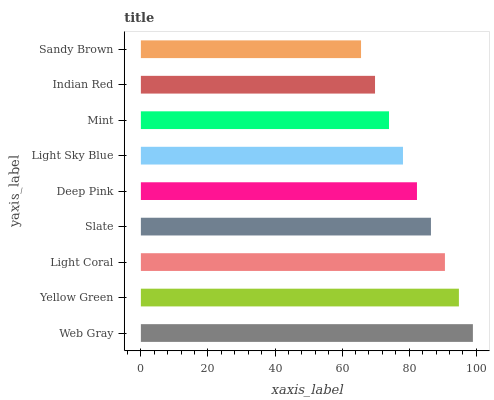Is Sandy Brown the minimum?
Answer yes or no. Yes. Is Web Gray the maximum?
Answer yes or no. Yes. Is Yellow Green the minimum?
Answer yes or no. No. Is Yellow Green the maximum?
Answer yes or no. No. Is Web Gray greater than Yellow Green?
Answer yes or no. Yes. Is Yellow Green less than Web Gray?
Answer yes or no. Yes. Is Yellow Green greater than Web Gray?
Answer yes or no. No. Is Web Gray less than Yellow Green?
Answer yes or no. No. Is Deep Pink the high median?
Answer yes or no. Yes. Is Deep Pink the low median?
Answer yes or no. Yes. Is Sandy Brown the high median?
Answer yes or no. No. Is Light Coral the low median?
Answer yes or no. No. 